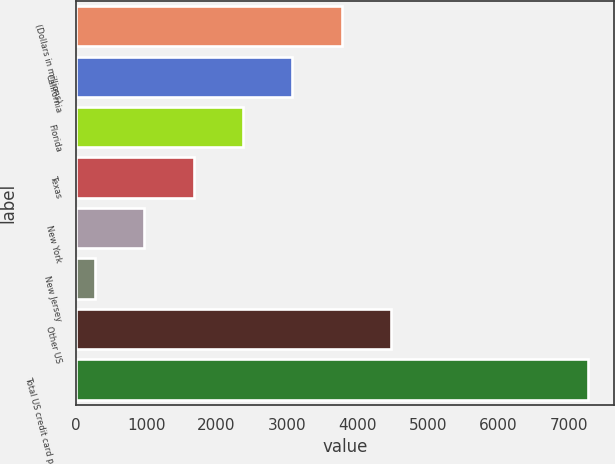Convert chart. <chart><loc_0><loc_0><loc_500><loc_500><bar_chart><fcel>(Dollars in millions)<fcel>California<fcel>Florida<fcel>Texas<fcel>New York<fcel>New Jersey<fcel>Other US<fcel>Total US credit card portfolio<nl><fcel>3775.5<fcel>3075.4<fcel>2375.3<fcel>1675.2<fcel>975.1<fcel>275<fcel>4475.6<fcel>7276<nl></chart> 